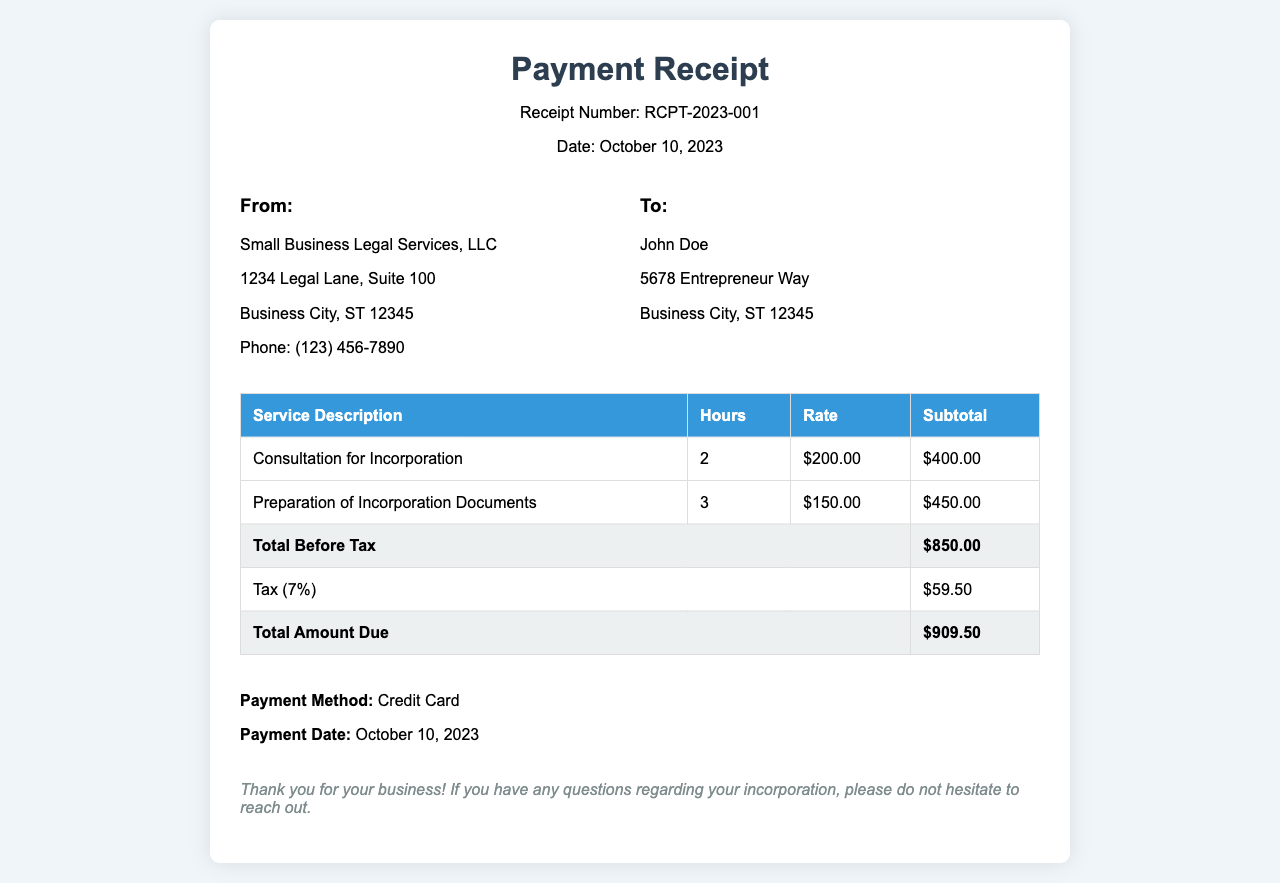What is the receipt number? The receipt number can be found near the top of the document, indicating its unique identifier.
Answer: RCPT-2023-001 Who provided the services? The name of the company providing the legal services is listed in the business information section of the document.
Answer: Small Business Legal Services, LLC How many hours were billed for the consultation? The document lists the hours billed for each service, specifically for the consultation.
Answer: 2 What is the subtotal for the preparation of incorporation documents? The subtotal can be found in the table under "Preparation of Incorporation Documents."
Answer: $450.00 What is the total amount due? The total amount due is found at the end of the billing table in the "Total Amount Due" row.
Answer: $909.50 What tax rate was applied on the services rendered? The document specifies the tax as a percentage applied to the total before tax.
Answer: 7% What is the payment method used? The payment method is indicated in the payment information section of the receipt.
Answer: Credit Card When was the payment made? The payment date is noted in the payment information section, showing when the transaction occurred.
Answer: October 10, 2023 What is the total before tax? The total before tax is found in the billing table under "Total Before Tax."
Answer: $850.00 